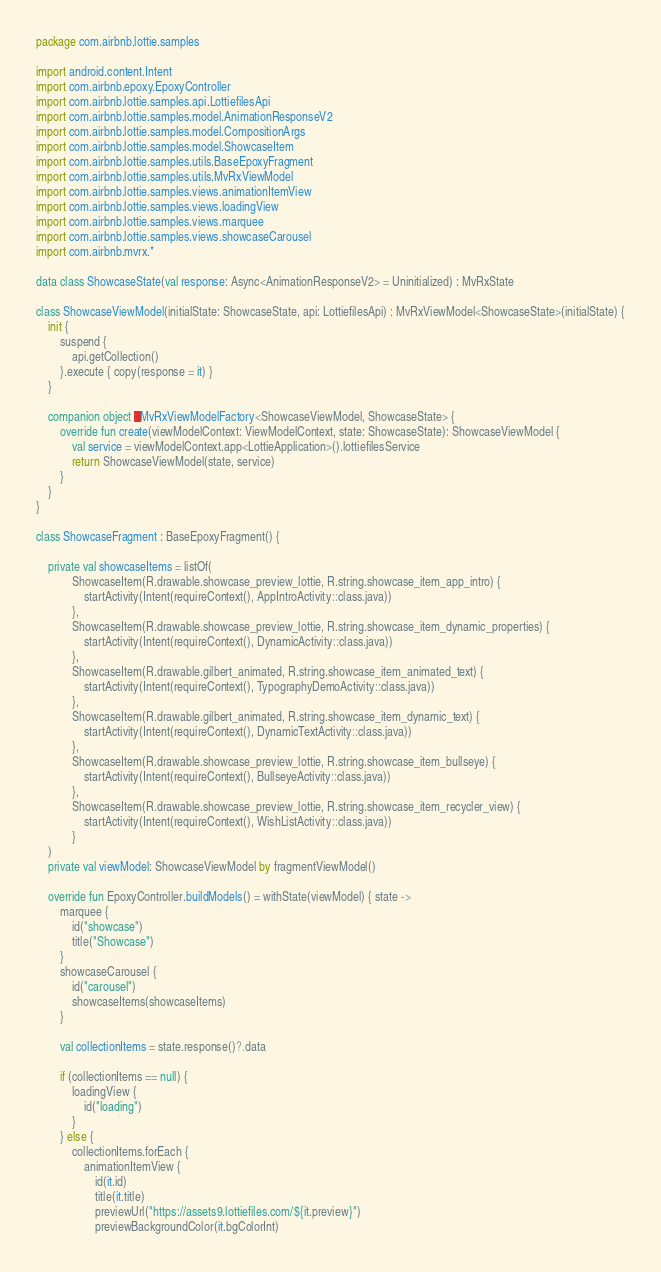Convert code to text. <code><loc_0><loc_0><loc_500><loc_500><_Kotlin_>package com.airbnb.lottie.samples

import android.content.Intent
import com.airbnb.epoxy.EpoxyController
import com.airbnb.lottie.samples.api.LottiefilesApi
import com.airbnb.lottie.samples.model.AnimationResponseV2
import com.airbnb.lottie.samples.model.CompositionArgs
import com.airbnb.lottie.samples.model.ShowcaseItem
import com.airbnb.lottie.samples.utils.BaseEpoxyFragment
import com.airbnb.lottie.samples.utils.MvRxViewModel
import com.airbnb.lottie.samples.views.animationItemView
import com.airbnb.lottie.samples.views.loadingView
import com.airbnb.lottie.samples.views.marquee
import com.airbnb.lottie.samples.views.showcaseCarousel
import com.airbnb.mvrx.*

data class ShowcaseState(val response: Async<AnimationResponseV2> = Uninitialized) : MvRxState

class ShowcaseViewModel(initialState: ShowcaseState, api: LottiefilesApi) : MvRxViewModel<ShowcaseState>(initialState) {
    init {
        suspend {
            api.getCollection()
        }.execute { copy(response = it) }
    }

    companion object : MvRxViewModelFactory<ShowcaseViewModel, ShowcaseState> {
        override fun create(viewModelContext: ViewModelContext, state: ShowcaseState): ShowcaseViewModel {
            val service = viewModelContext.app<LottieApplication>().lottiefilesService
            return ShowcaseViewModel(state, service)
        }
    }
}

class ShowcaseFragment : BaseEpoxyFragment() {

    private val showcaseItems = listOf(
            ShowcaseItem(R.drawable.showcase_preview_lottie, R.string.showcase_item_app_intro) {
                startActivity(Intent(requireContext(), AppIntroActivity::class.java))
            },
            ShowcaseItem(R.drawable.showcase_preview_lottie, R.string.showcase_item_dynamic_properties) {
                startActivity(Intent(requireContext(), DynamicActivity::class.java))
            },
            ShowcaseItem(R.drawable.gilbert_animated, R.string.showcase_item_animated_text) {
                startActivity(Intent(requireContext(), TypographyDemoActivity::class.java))
            },
            ShowcaseItem(R.drawable.gilbert_animated, R.string.showcase_item_dynamic_text) {
                startActivity(Intent(requireContext(), DynamicTextActivity::class.java))
            },
            ShowcaseItem(R.drawable.showcase_preview_lottie, R.string.showcase_item_bullseye) {
                startActivity(Intent(requireContext(), BullseyeActivity::class.java))
            },
            ShowcaseItem(R.drawable.showcase_preview_lottie, R.string.showcase_item_recycler_view) {
                startActivity(Intent(requireContext(), WishListActivity::class.java))
            }
    )
    private val viewModel: ShowcaseViewModel by fragmentViewModel()

    override fun EpoxyController.buildModels() = withState(viewModel) { state ->
        marquee {
            id("showcase")
            title("Showcase")
        }
        showcaseCarousel {
            id("carousel")
            showcaseItems(showcaseItems)
        }

        val collectionItems = state.response()?.data

        if (collectionItems == null) {
            loadingView {
                id("loading")
            }
        } else {
            collectionItems.forEach {
                animationItemView {
                    id(it.id)
                    title(it.title)
                    previewUrl("https://assets9.lottiefiles.com/${it.preview}")
                    previewBackgroundColor(it.bgColorInt)</code> 